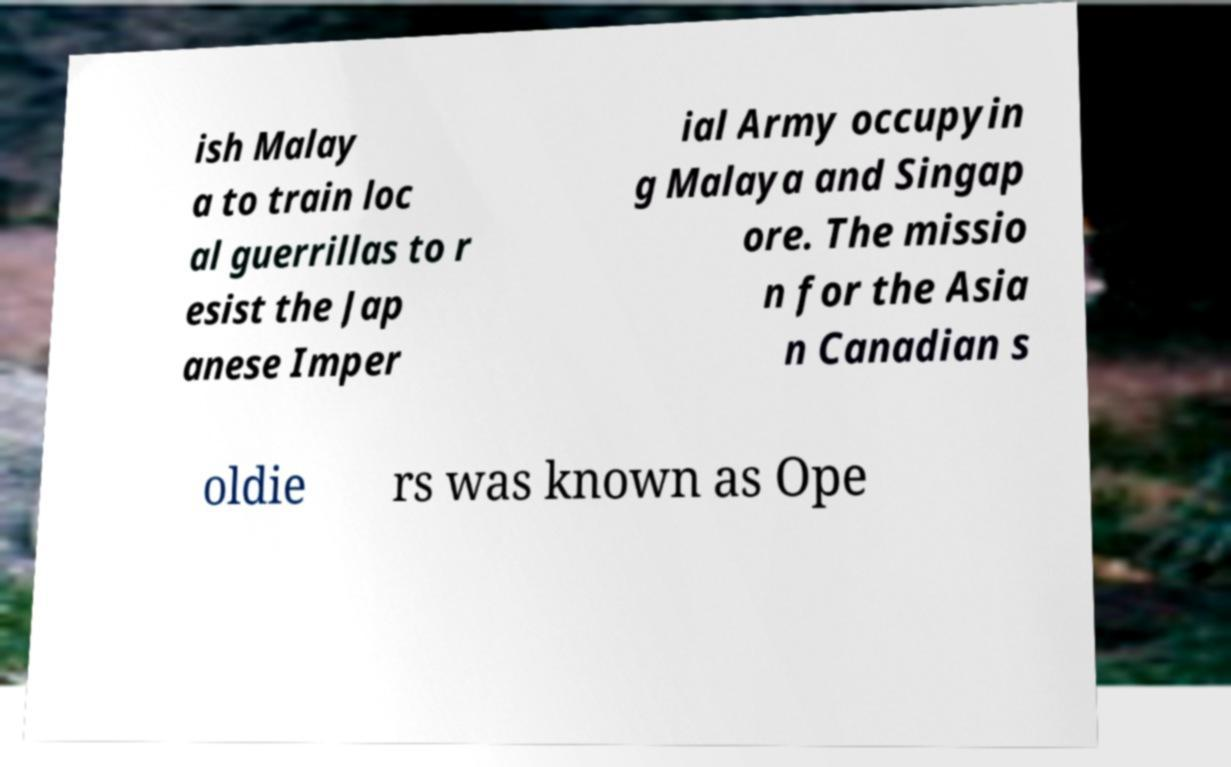Could you extract and type out the text from this image? ish Malay a to train loc al guerrillas to r esist the Jap anese Imper ial Army occupyin g Malaya and Singap ore. The missio n for the Asia n Canadian s oldie rs was known as Ope 